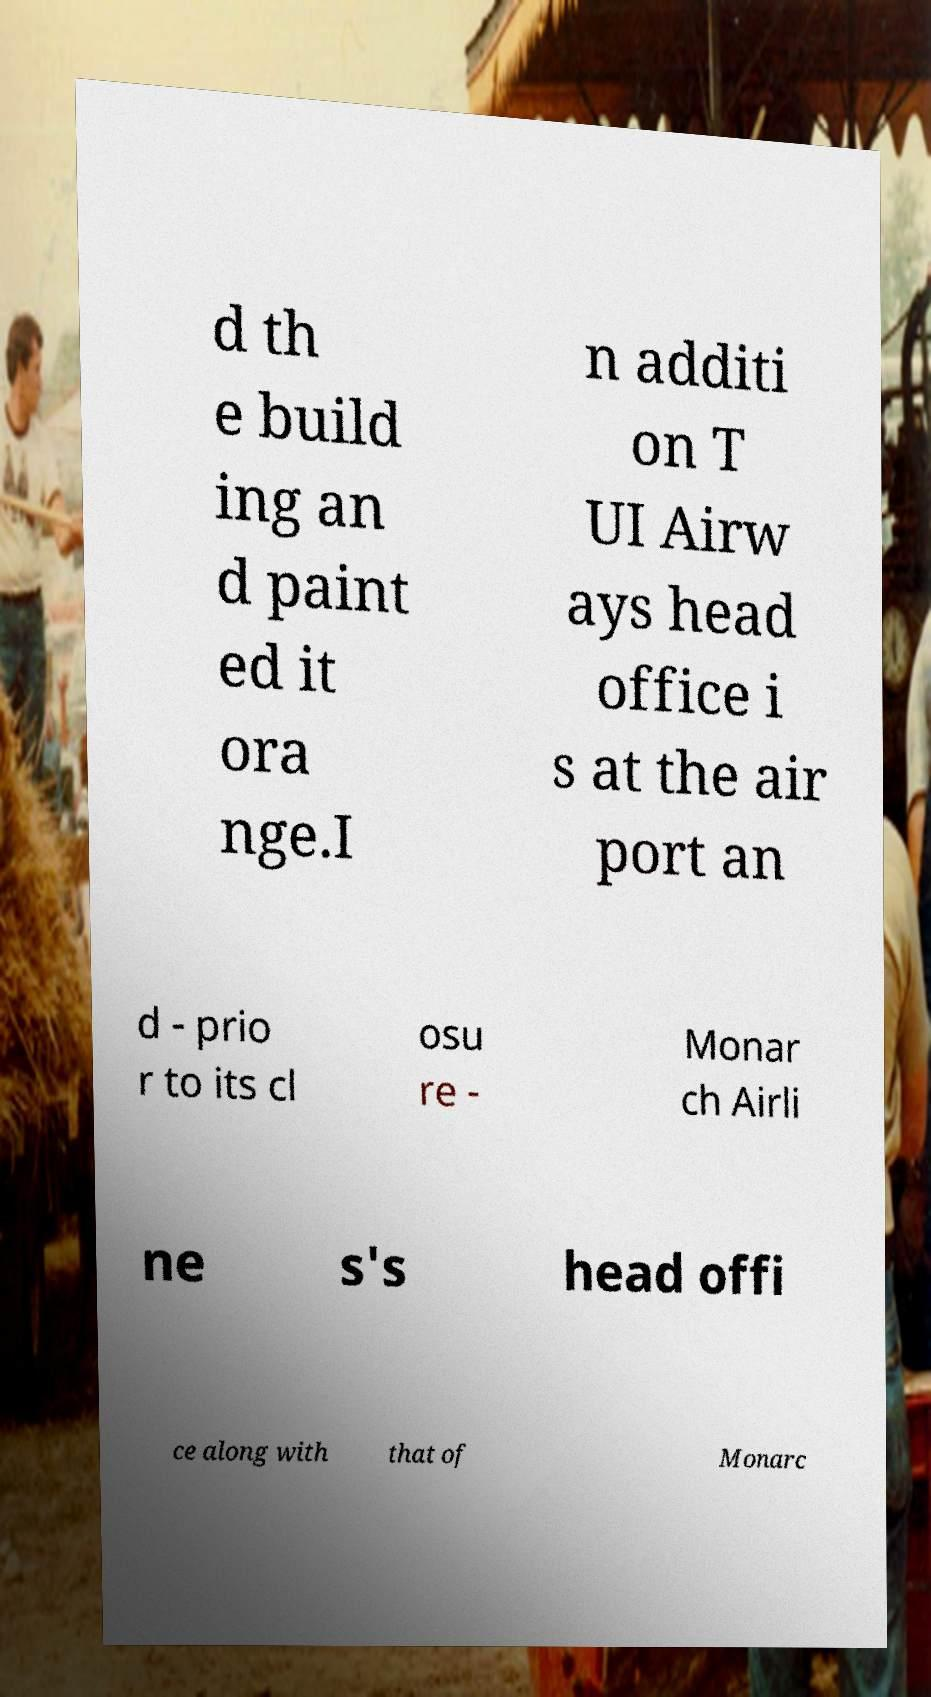I need the written content from this picture converted into text. Can you do that? d th e build ing an d paint ed it ora nge.I n additi on T UI Airw ays head office i s at the air port an d - prio r to its cl osu re - Monar ch Airli ne s's head offi ce along with that of Monarc 